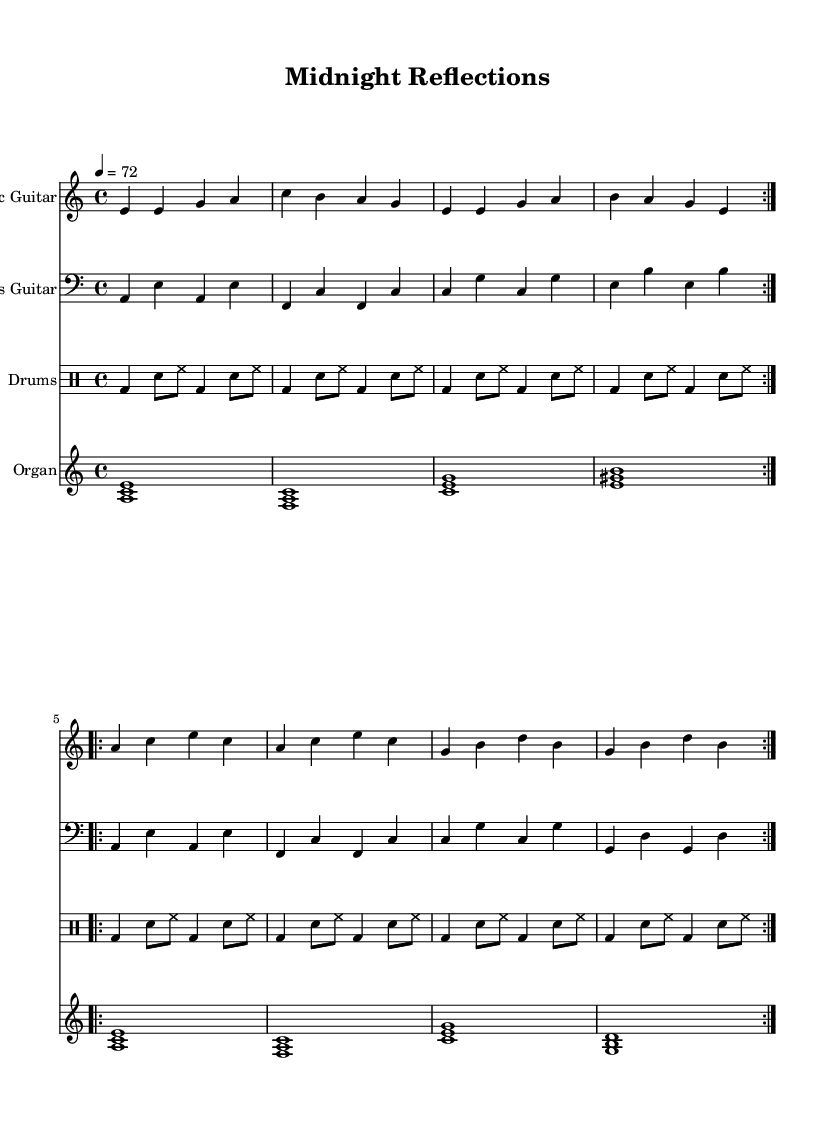What is the key signature of this music? The key signature shows one flat, which indicates the piece is in A minor. This can be confirmed by looking at the key signature marker at the beginning of the staff.
Answer: A minor What is the time signature of this piece? The time signature indicated at the start of the sheet is 4/4, meaning there are four beats in each measure and a quarter note gets one beat. This is visually recognizable near the beginning of the sheet music.
Answer: 4/4 What is the tempo marking for this composition? The tempo marking "4 = 72" specifies that there should be 72 beats per minute, indicating a medium slow pace for the music. This can be found near the beginning, likely right after the key and time signature.
Answer: 72 How many measures are there in the electric guitar part? By counting the repeated sections and measures in the electric guitar part, one finds there are 16 measures in total, split evenly between the two repeats. Each repeat contains 8 measures, leading to a total of 16.
Answer: 16 Which instrument plays the heavy drum solos in this arrangement? The drums part, labeled in the music sheet, is where the heavy drum solos would occur as indicated by the drum notation that includes bass drums and snare hits typical of an energetic style.
Answer: Drums What is the texture of this music piece in terms of instrumental layering? The music features a layered texture with an electric guitar, bass guitar, drums, and organ playing simultaneously, creating a rich, combined sound typical of modern electric blues. This is evident from the multiple staves present in the sheet music.
Answer: Layered What type of lyrical theme can be inferred from the title "Midnight Reflections"? The title suggests introspective themes, commonly found in blues music, indicating a reflective or contemplative lyrical approach often dealing with deep emotions or experiences, typical characteristics of blues lyrics.
Answer: Introspective 